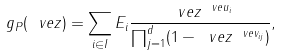<formula> <loc_0><loc_0><loc_500><loc_500>g _ { P } ( \ v e z ) = \sum _ { i \in I } { E _ { i } \frac { \ v e z ^ { \ v e u _ { i } } } { \prod _ { j = 1 } ^ { d } ( 1 - \ v e z ^ { \ v e v _ { i j } } ) } } ,</formula> 